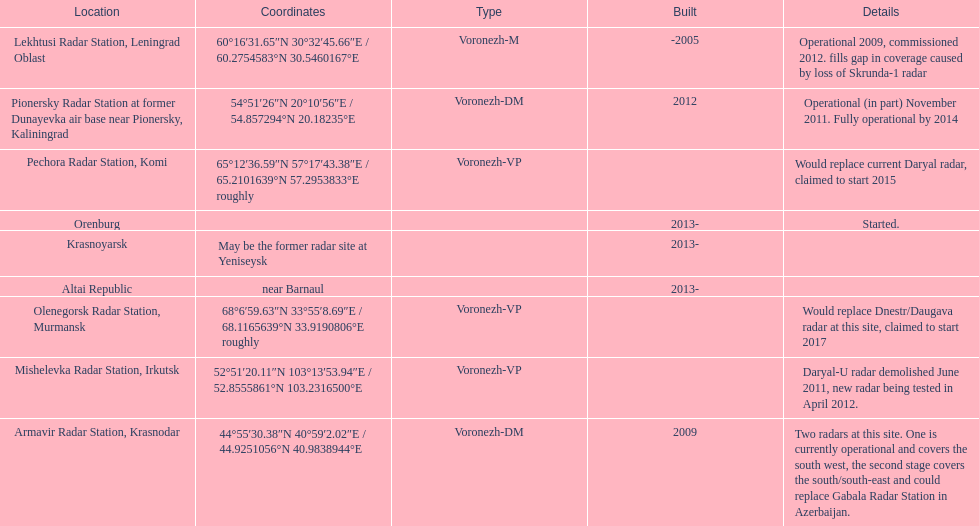What is the only radar that will start in 2015? Pechora Radar Station, Komi. 